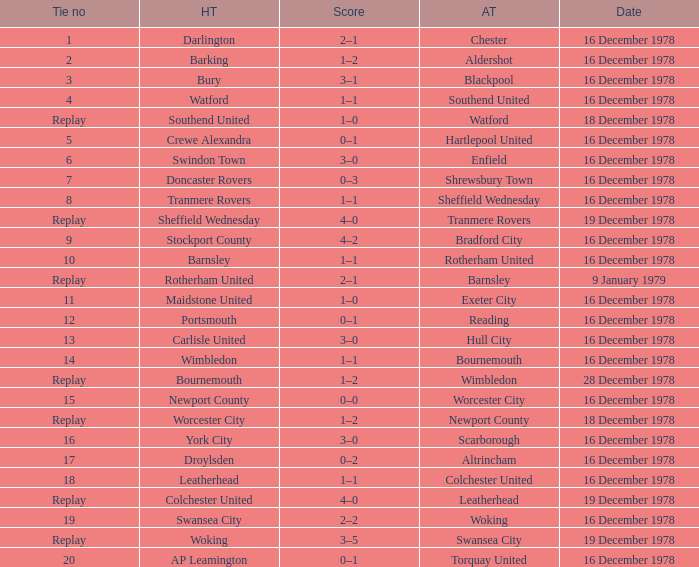Could you parse the entire table? {'header': ['Tie no', 'HT', 'Score', 'AT', 'Date'], 'rows': [['1', 'Darlington', '2–1', 'Chester', '16 December 1978'], ['2', 'Barking', '1–2', 'Aldershot', '16 December 1978'], ['3', 'Bury', '3–1', 'Blackpool', '16 December 1978'], ['4', 'Watford', '1–1', 'Southend United', '16 December 1978'], ['Replay', 'Southend United', '1–0', 'Watford', '18 December 1978'], ['5', 'Crewe Alexandra', '0–1', 'Hartlepool United', '16 December 1978'], ['6', 'Swindon Town', '3–0', 'Enfield', '16 December 1978'], ['7', 'Doncaster Rovers', '0–3', 'Shrewsbury Town', '16 December 1978'], ['8', 'Tranmere Rovers', '1–1', 'Sheffield Wednesday', '16 December 1978'], ['Replay', 'Sheffield Wednesday', '4–0', 'Tranmere Rovers', '19 December 1978'], ['9', 'Stockport County', '4–2', 'Bradford City', '16 December 1978'], ['10', 'Barnsley', '1–1', 'Rotherham United', '16 December 1978'], ['Replay', 'Rotherham United', '2–1', 'Barnsley', '9 January 1979'], ['11', 'Maidstone United', '1–0', 'Exeter City', '16 December 1978'], ['12', 'Portsmouth', '0–1', 'Reading', '16 December 1978'], ['13', 'Carlisle United', '3–0', 'Hull City', '16 December 1978'], ['14', 'Wimbledon', '1–1', 'Bournemouth', '16 December 1978'], ['Replay', 'Bournemouth', '1–2', 'Wimbledon', '28 December 1978'], ['15', 'Newport County', '0–0', 'Worcester City', '16 December 1978'], ['Replay', 'Worcester City', '1–2', 'Newport County', '18 December 1978'], ['16', 'York City', '3–0', 'Scarborough', '16 December 1978'], ['17', 'Droylsden', '0–2', 'Altrincham', '16 December 1978'], ['18', 'Leatherhead', '1–1', 'Colchester United', '16 December 1978'], ['Replay', 'Colchester United', '4–0', 'Leatherhead', '19 December 1978'], ['19', 'Swansea City', '2–2', 'Woking', '16 December 1978'], ['Replay', 'Woking', '3–5', 'Swansea City', '19 December 1978'], ['20', 'AP Leamington', '0–1', 'Torquay United', '16 December 1978']]} Waht was the away team when the home team is colchester united? Leatherhead. 